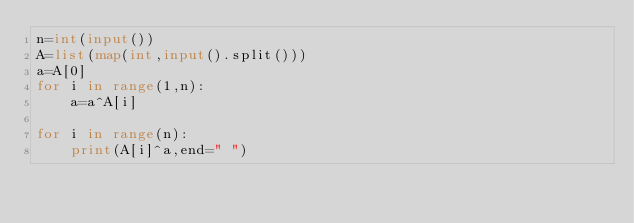Convert code to text. <code><loc_0><loc_0><loc_500><loc_500><_Python_>n=int(input())
A=list(map(int,input().split()))
a=A[0]
for i in range(1,n):
    a=a^A[i]

for i in range(n):
    print(A[i]^a,end=" ")</code> 